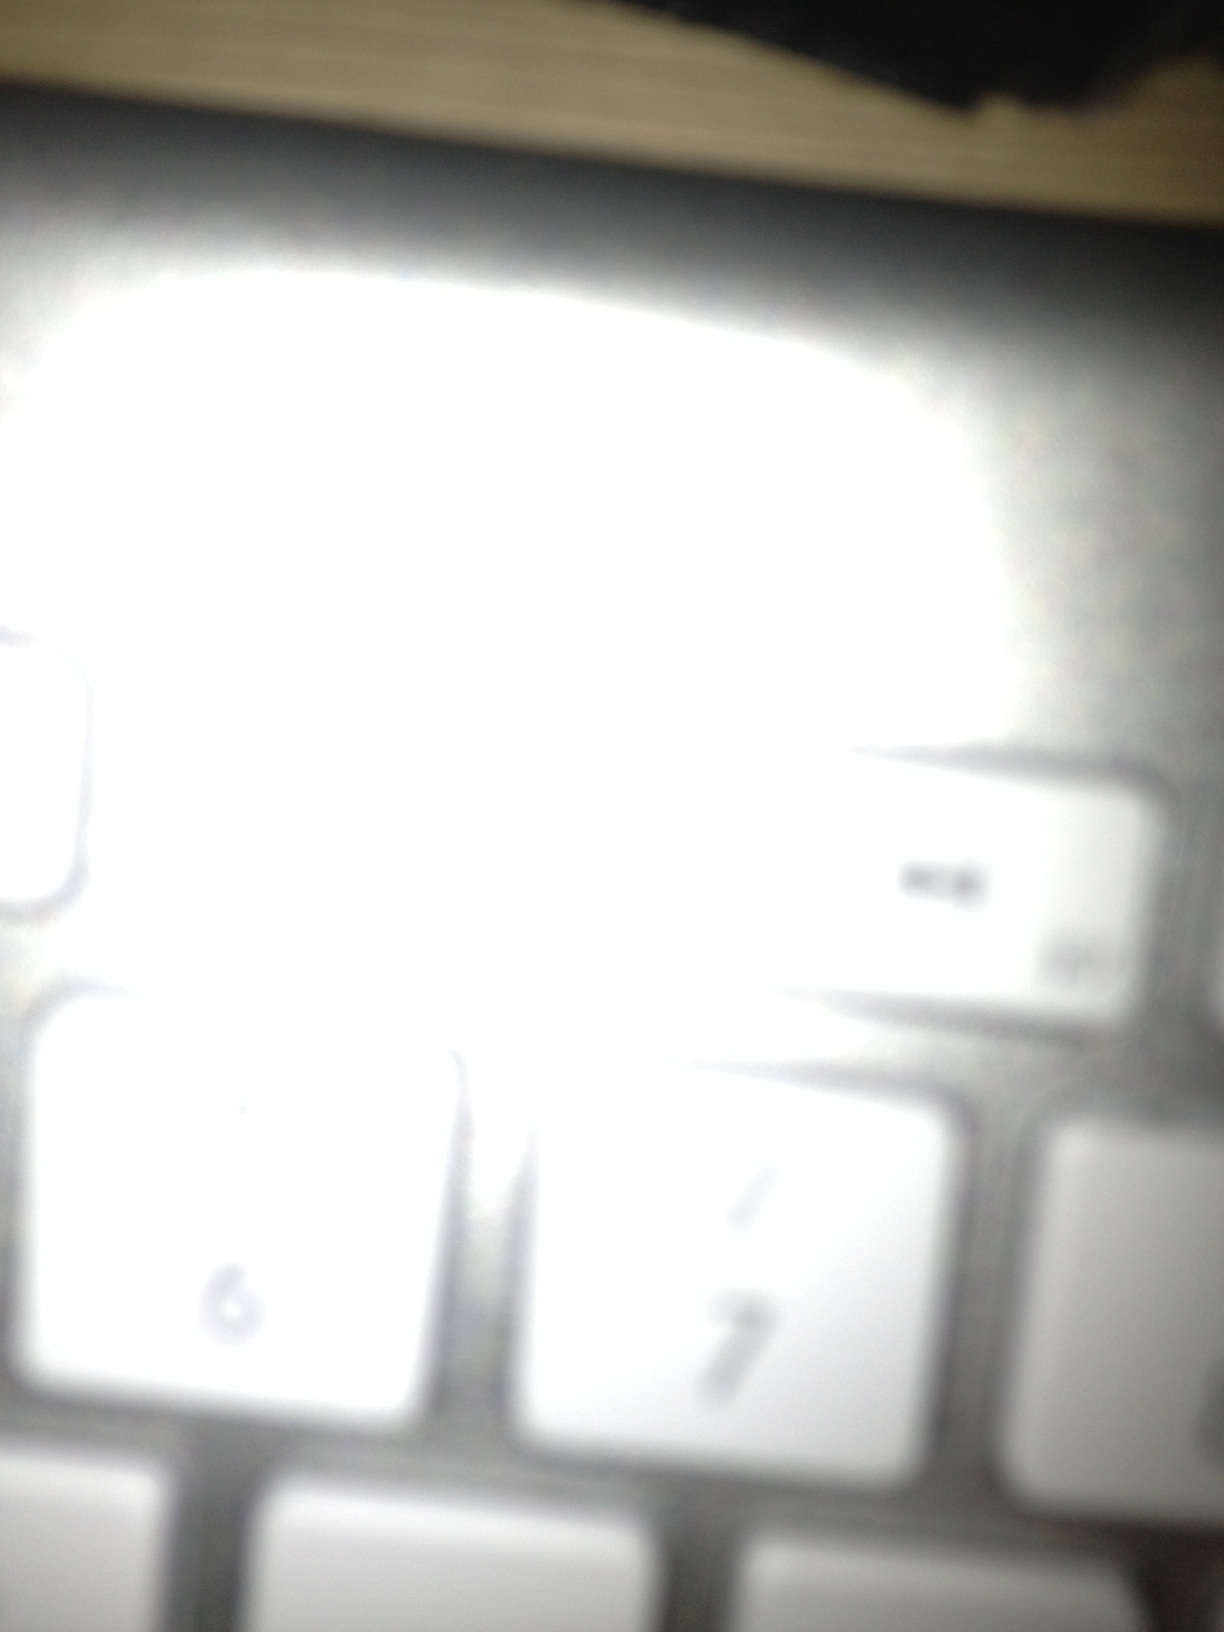What can we infer about the user's habits from this keyboard image? Based on the image, we can infer that the user likely spends considerable time typing, given the wear visible on the number keys 6 and 7. The blur suggests the user may have taken this photo hurriedly, perhaps indicating a fast-paced work environment or lifestyle. The overexposure might hint that the photo was taken in a brightly lit area, possibly an office or a desk with a strong light source. Imagine the keyboard could reveal secrets about its past owners. Create a short story. Once belonging to a renowned journalist, this keyboard was a silent witness to many groundbreaking stories. Each keystroke echoed tales of political intrigues, untold truths, and clandestine meetings in dimly lit cafes. Over the years, it was passed down to an aspiring novelist, who spent nights bringing fictional worlds to life, keying in dialogues and crafting plot twists. Its most recent owner, a software developer, coded solutions to complex problems, often accompanied by the soft hum of a coffee maker in the background. Through every user, the keyboard absorbed a part of their essence, becoming a repository of unspoken words and untold stories. 